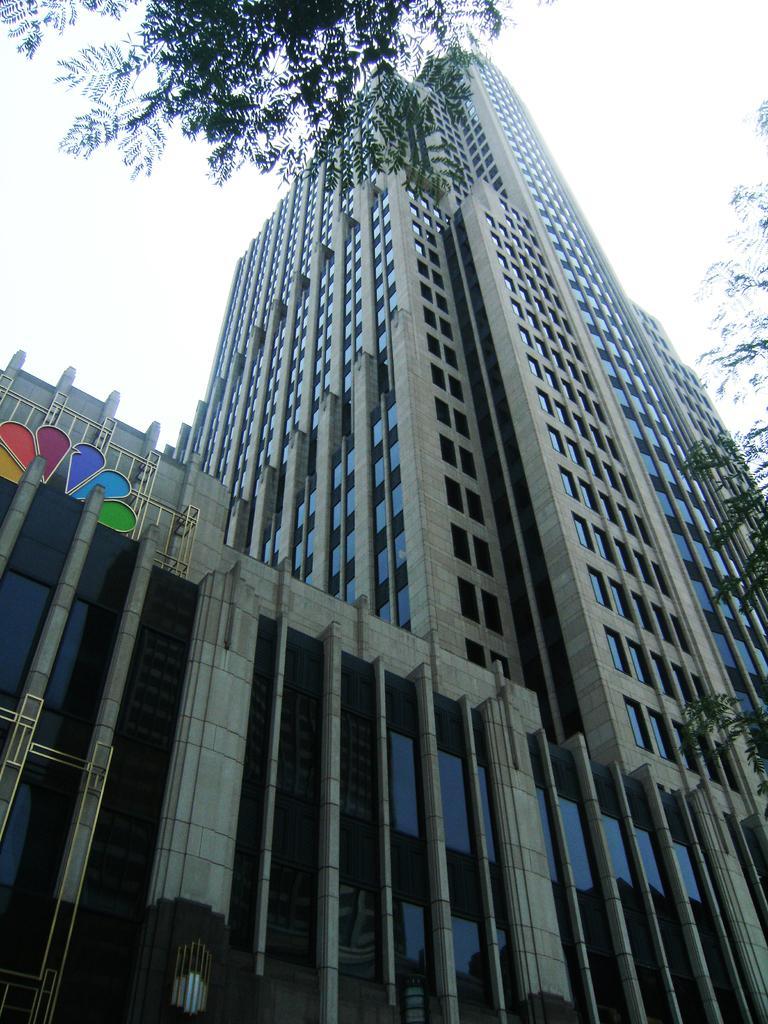In one or two sentences, can you explain what this image depicts? There is a tower building and there are trees beside it. 